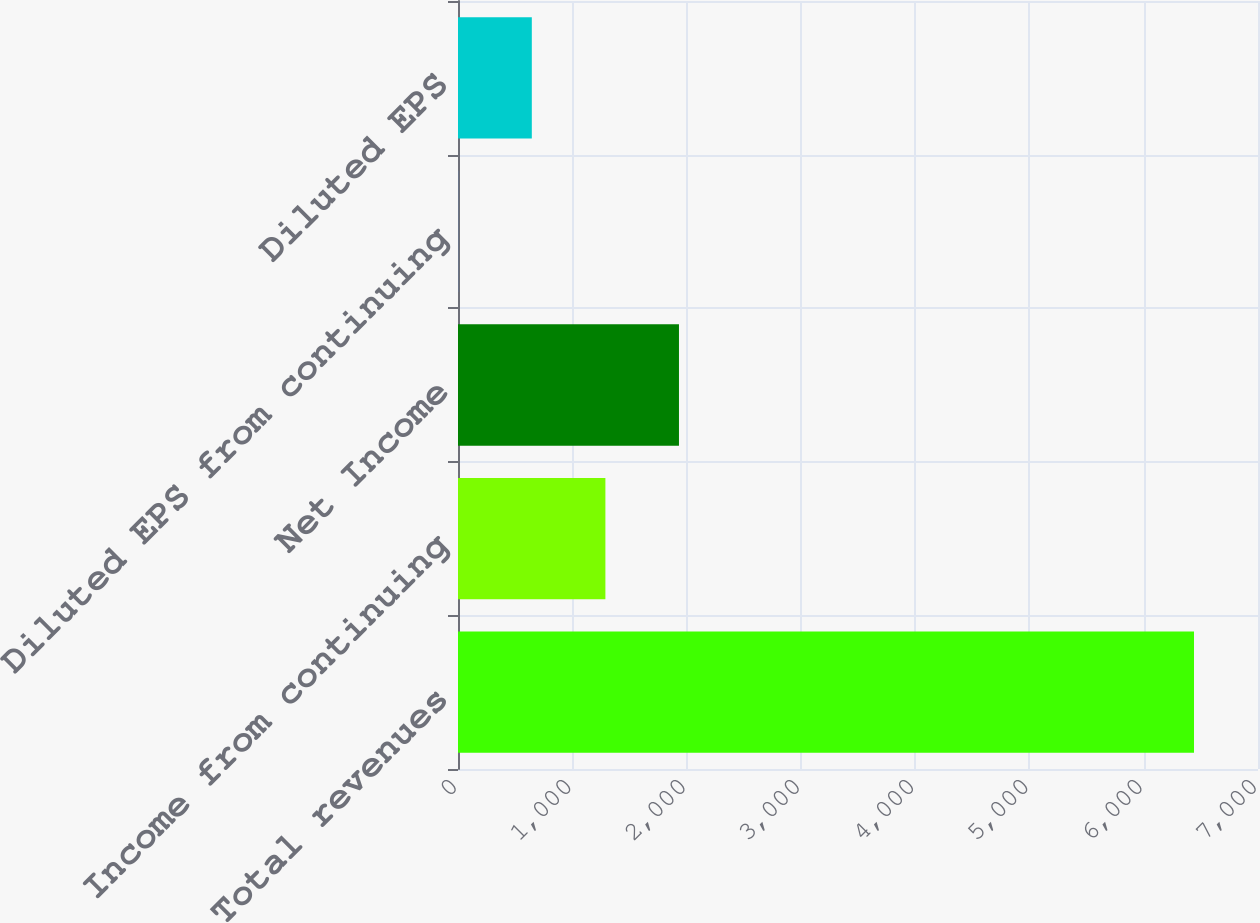Convert chart. <chart><loc_0><loc_0><loc_500><loc_500><bar_chart><fcel>Total revenues<fcel>Income from continuing<fcel>Net Income<fcel>Diluted EPS from continuing<fcel>Diluted EPS<nl><fcel>6440<fcel>1289.69<fcel>1933.48<fcel>2.11<fcel>645.9<nl></chart> 